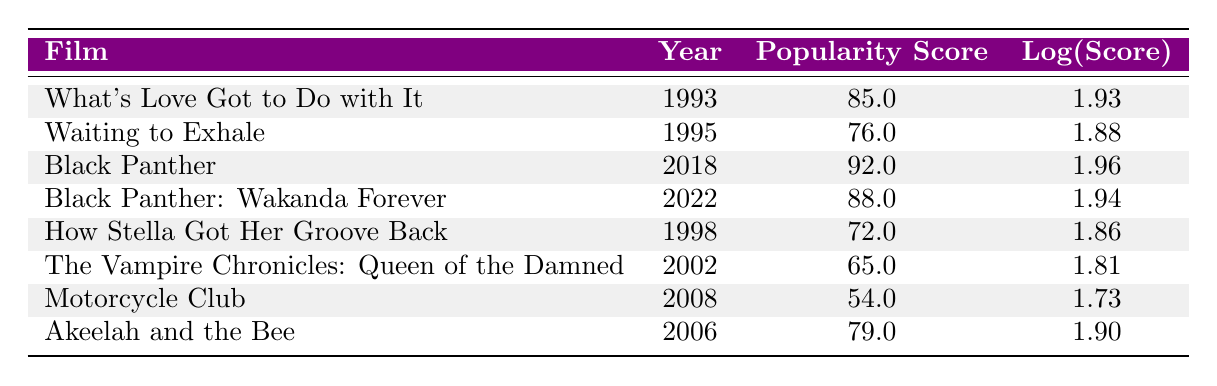What is the highest popularity score among Angela Bassett's films? The table displays the popularity scores of various films. By reviewing the scores, "Black Panther" has the highest score at 92.
Answer: 92 Which film was released in 1995? The table lists the years alongside the films. The film listed for the year 1995 is "Waiting to Exhale."
Answer: Waiting to Exhale What is the difference in popularity scores between "What’s Love Got to Do with It" and "How Stella Got Her Groove Back"? "What's Love Got to Do with It" has a score of 85 and "How Stella Got Her Groove Back" has a score of 72. The difference is 85 - 72 = 13.
Answer: 13 Which film has a higher popularity score: "Akeelah and the Bee" or "Motorcycle Club"? "Akeelah and the Bee" has a popularity score of 79, while "Motorcycle Club" has a score of 54. Comparing the two, 79 is greater than 54.
Answer: Akeelah and the Bee Is it true that "Black Panther: Wakanda Forever" has a higher log score than "Waiting to Exhale"? The log score for "Black Panther: Wakanda Forever" is 1.94, while for "Waiting to Exhale" it is 1.88. Since 1.94 is greater than 1.88, the statement is true.
Answer: Yes What is the average popularity score of all the films listed in the table? We sum the scores: 85 + 76 + 92 + 88 + 72 + 65 + 54 + 79 = 511. There are 8 films, so the average is 511 / 8 = 63.875.
Answer: 63.875 Which decade saw the release of the most films featuring Angela Bassett? By examining the years of release, the 1990s saw three films (1993, 1995, 1998), while the other decades had fewer. Thus, the 1990s had the most films.
Answer: 1990s Which two films have the closest popularity scores? Reviewing the scores, "Waiting to Exhale" (76) and "How Stella Got Her Groove Back" (72) have the closest scores, differing by 4.
Answer: Waiting to Exhale and How Stella Got Her Groove Back 